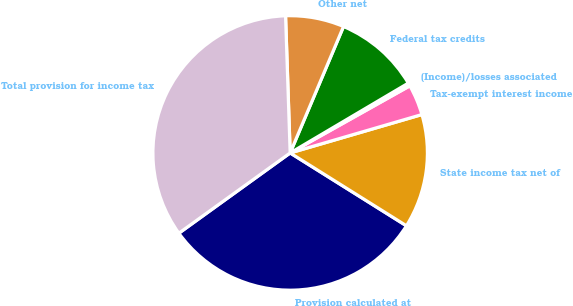Convert chart. <chart><loc_0><loc_0><loc_500><loc_500><pie_chart><fcel>Provision calculated at<fcel>State income tax net of<fcel>Tax-exempt interest income<fcel>(Income)/losses associated<fcel>Federal tax credits<fcel>Other net<fcel>Total provision for income tax<nl><fcel>31.15%<fcel>13.42%<fcel>3.62%<fcel>0.36%<fcel>10.15%<fcel>6.89%<fcel>34.41%<nl></chart> 